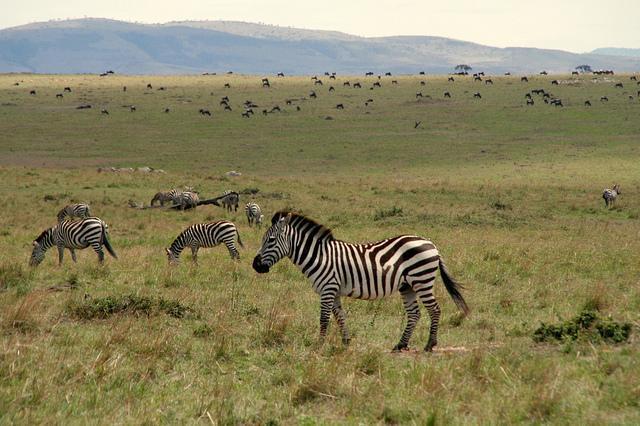How many zebra?
Give a very brief answer. 8. How many zebras are there?
Give a very brief answer. 2. 